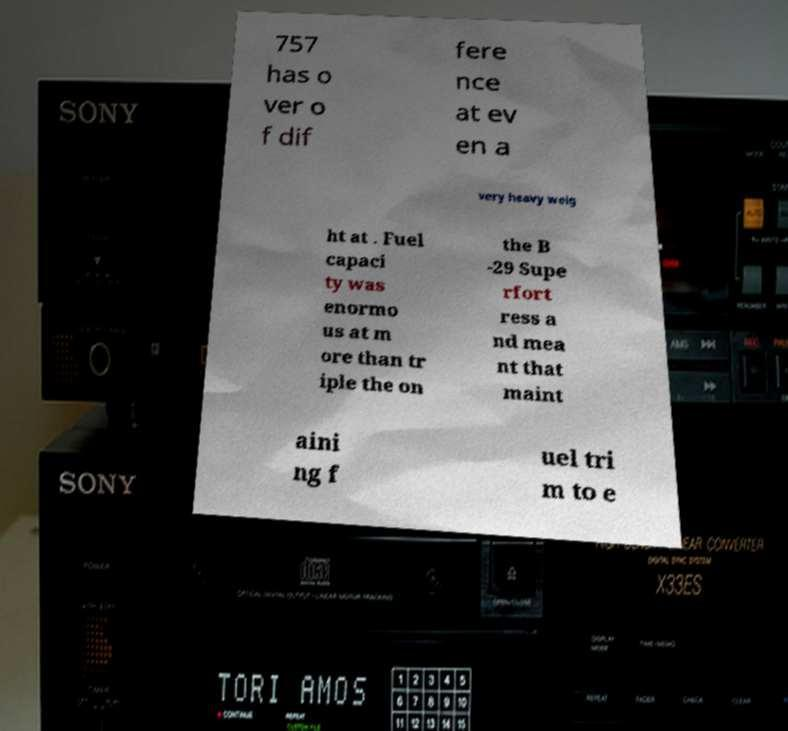What messages or text are displayed in this image? I need them in a readable, typed format. 757 has o ver o f dif fere nce at ev en a very heavy weig ht at . Fuel capaci ty was enormo us at m ore than tr iple the on the B -29 Supe rfort ress a nd mea nt that maint aini ng f uel tri m to e 